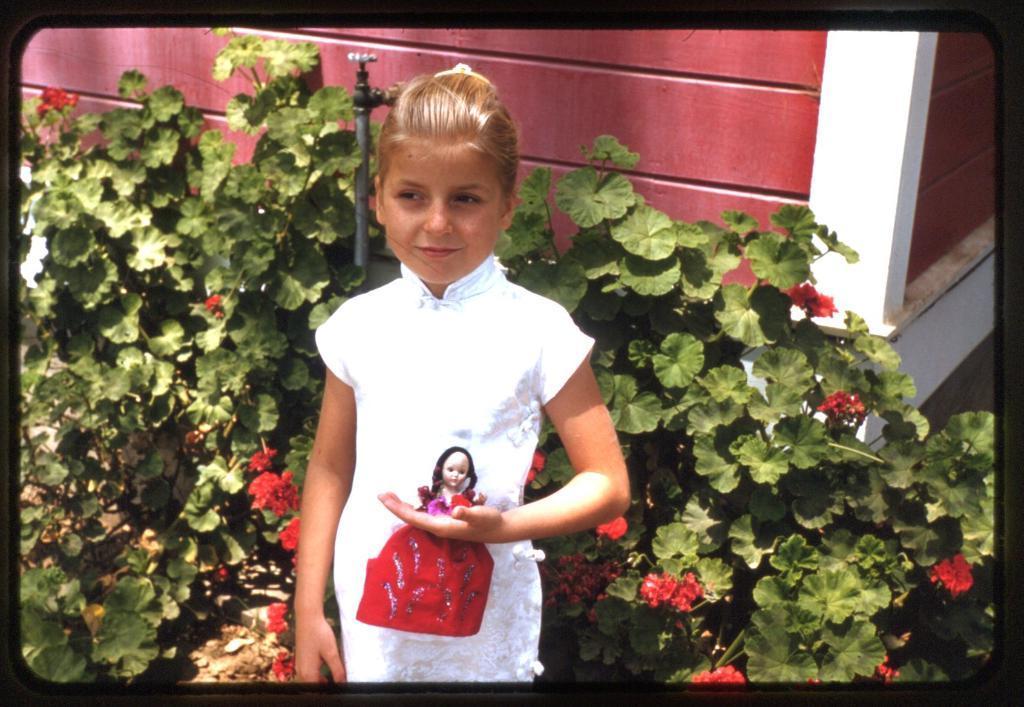How would you summarize this image in a sentence or two? In this image there is a girl holding a doll in her hand, behind the girl, there are flowers and leaves of a plant and there is a tap on the wall. 